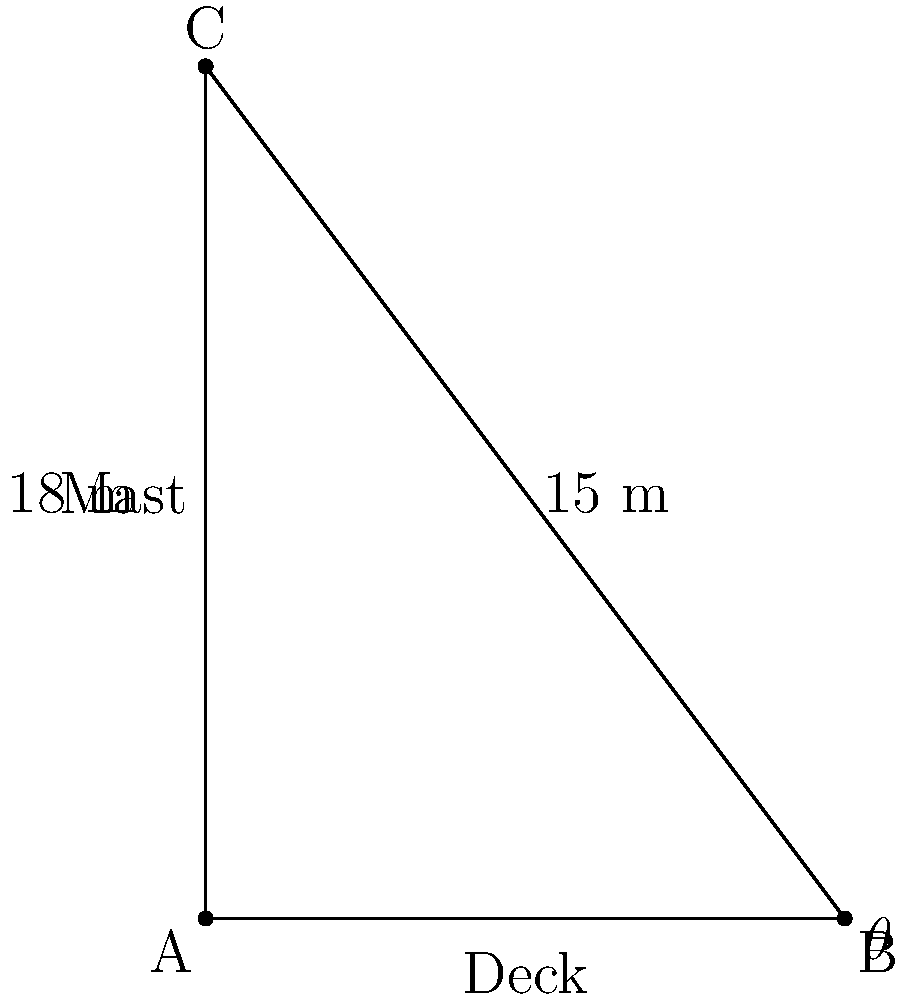On the "Purga", you notice that the main mast forms a right angle with the deck. The distance from the base of the mast to a point directly below the top of the mast on the deck is 15 meters, and the height of the mast is 18 meters. What is the angle $\theta$ between the mast and the deck? Let's approach this step-by-step using trigonometry:

1) We have a right-angled triangle where:
   - The base (adjacent to angle $\theta$) is 15 meters
   - The height (opposite to angle $\theta$) is 18 meters
   - The hypotenuse is the mast itself

2) To find the angle $\theta$, we can use the tangent function:

   $\tan(\theta) = \frac{\text{opposite}}{\text{adjacent}} = \frac{18}{15}$

3) To get the angle, we need to use the inverse tangent (arctan or $\tan^{-1}$):

   $\theta = \tan^{-1}(\frac{18}{15})$

4) Using a calculator or trigonometric tables:

   $\theta = \tan^{-1}(1.2) \approx 50.2°$

5) Rounding to the nearest degree:

   $\theta \approx 50°$

Thus, the angle between the mast and the deck is approximately 50 degrees.
Answer: $50°$ 